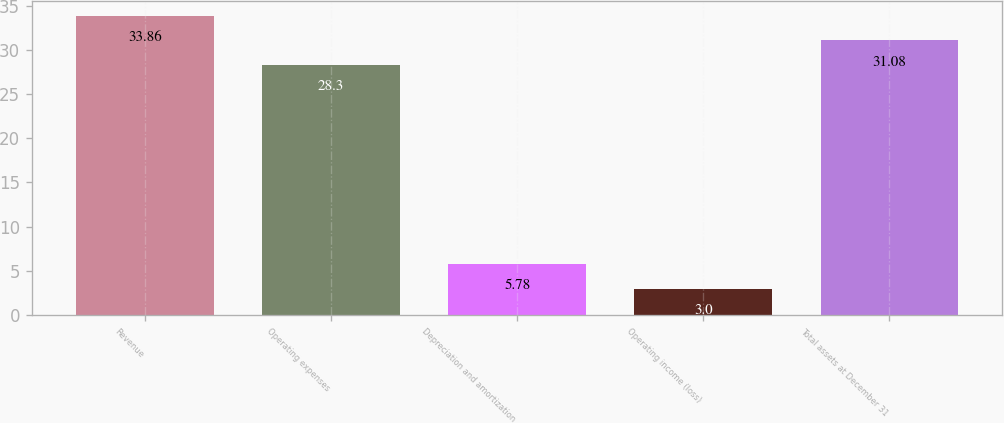Convert chart. <chart><loc_0><loc_0><loc_500><loc_500><bar_chart><fcel>Revenue<fcel>Operating expenses<fcel>Depreciation and amortization<fcel>Operating income (loss)<fcel>Total assets at December 31<nl><fcel>33.86<fcel>28.3<fcel>5.78<fcel>3<fcel>31.08<nl></chart> 